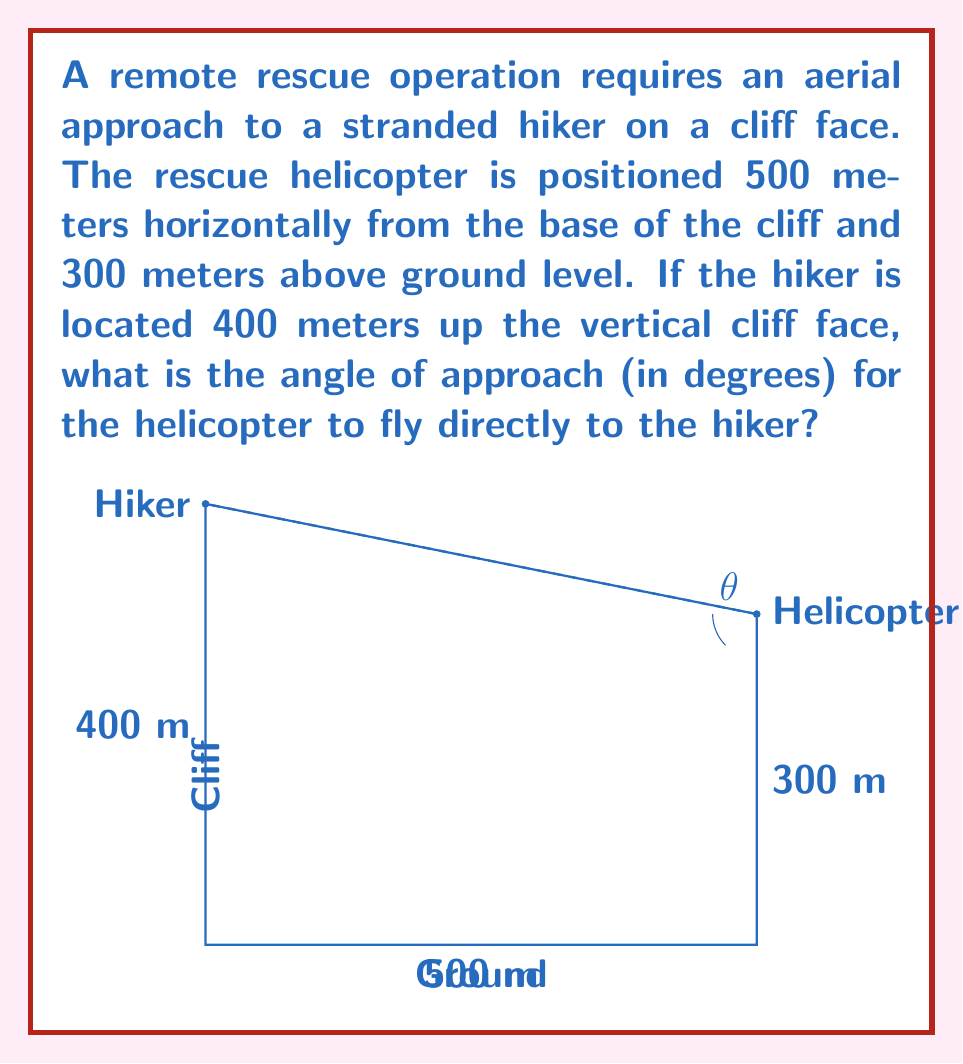Provide a solution to this math problem. To solve this problem, we need to use trigonometry in a right triangle. Let's break it down step-by-step:

1) First, we need to identify the right triangle formed by the helicopter's position, the hiker's position, and the point directly below the helicopter on the ground.

2) In this triangle:
   - The base (adjacent to our angle) is 500 meters (horizontal distance from cliff)
   - The height is the difference between the hiker's height and the helicopter's height:
     400 m - 300 m = 100 m

3) We want to find the angle of approach, which is the angle between the helicopter's path and the horizontal.

4) We can use the arctangent function to find this angle. The tangent of an angle in a right triangle is the opposite side divided by the adjacent side.

5) Let $\theta$ be our angle of approach. Then:

   $$\tan(\theta) = \frac{\text{opposite}}{\text{adjacent}} = \frac{100}{500} = \frac{1}{5} = 0.2$$

6) To find $\theta$, we take the arctangent (inverse tangent) of both sides:

   $$\theta = \arctan(0.2)$$

7) Using a calculator or computer, we can evaluate this:

   $$\theta \approx 11.3099325^\circ$$

8) Rounding to the nearest tenth of a degree:

   $$\theta \approx 11.3^\circ$$
Answer: $11.3^\circ$ 